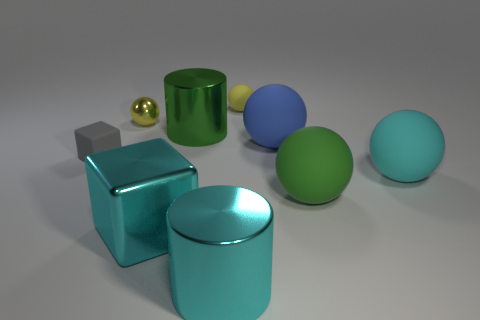What number of large spheres are left of the yellow matte thing that is on the right side of the block that is in front of the large cyan ball? Upon examination, there are no large spheres to the left of the yellow matte object. The yellow object sits to the right of the silver block, which in turn is in front of the large cyan ball, with no large spheres in the specified area. 